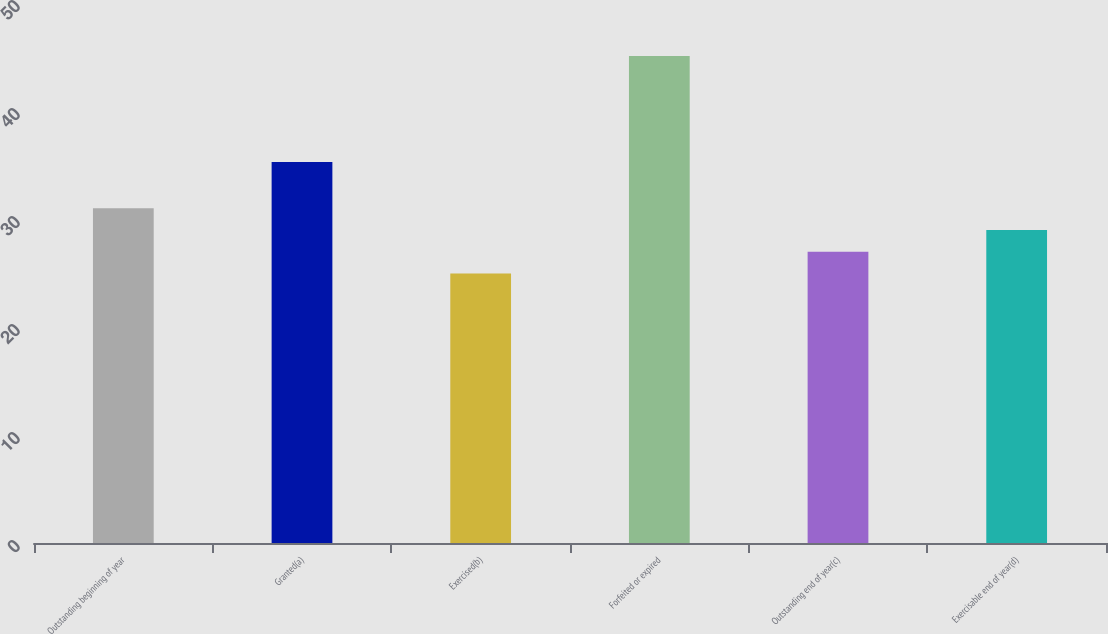Convert chart to OTSL. <chart><loc_0><loc_0><loc_500><loc_500><bar_chart><fcel>Outstanding beginning of year<fcel>Granted(a)<fcel>Exercised(b)<fcel>Forfeited or expired<fcel>Outstanding end of year(c)<fcel>Exercisable end of year(d)<nl><fcel>30.99<fcel>35.27<fcel>24.95<fcel>45.09<fcel>26.97<fcel>28.98<nl></chart> 